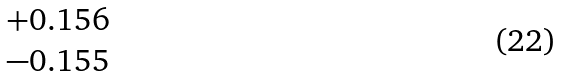Convert formula to latex. <formula><loc_0><loc_0><loc_500><loc_500>\begin{matrix} + 0 . 1 5 6 \\ - 0 . 1 5 5 \end{matrix}</formula> 